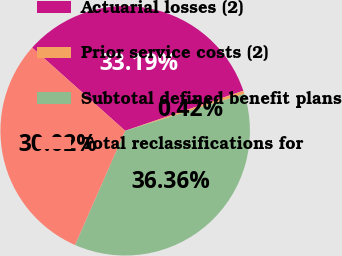<chart> <loc_0><loc_0><loc_500><loc_500><pie_chart><fcel>Actuarial losses (2)<fcel>Prior service costs (2)<fcel>Subtotal defined benefit plans<fcel>Total reclassifications for<nl><fcel>33.19%<fcel>0.42%<fcel>36.36%<fcel>30.02%<nl></chart> 